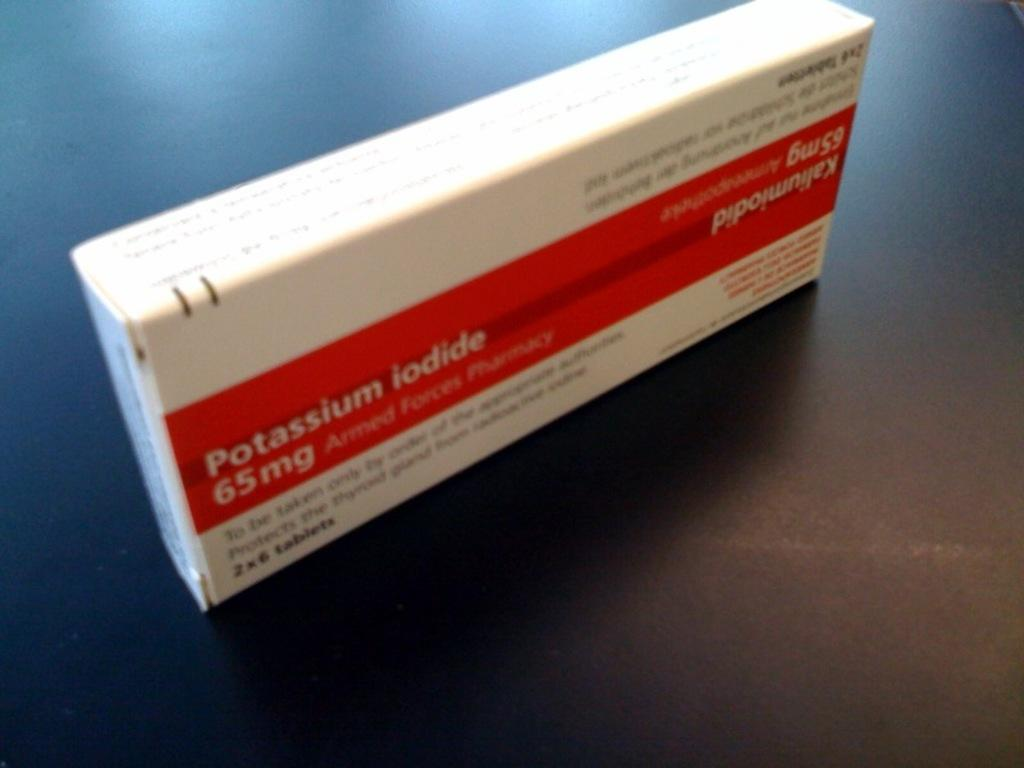<image>
Provide a brief description of the given image. a red and white box of potassium iodide 